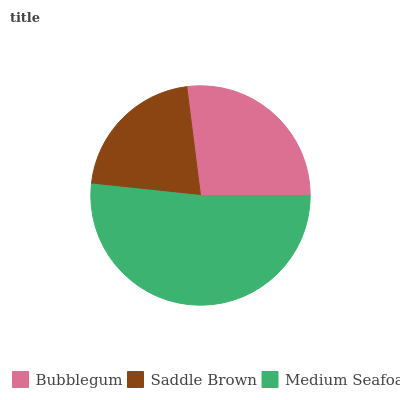Is Saddle Brown the minimum?
Answer yes or no. Yes. Is Medium Seafoam the maximum?
Answer yes or no. Yes. Is Medium Seafoam the minimum?
Answer yes or no. No. Is Saddle Brown the maximum?
Answer yes or no. No. Is Medium Seafoam greater than Saddle Brown?
Answer yes or no. Yes. Is Saddle Brown less than Medium Seafoam?
Answer yes or no. Yes. Is Saddle Brown greater than Medium Seafoam?
Answer yes or no. No. Is Medium Seafoam less than Saddle Brown?
Answer yes or no. No. Is Bubblegum the high median?
Answer yes or no. Yes. Is Bubblegum the low median?
Answer yes or no. Yes. Is Medium Seafoam the high median?
Answer yes or no. No. Is Medium Seafoam the low median?
Answer yes or no. No. 